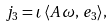Convert formula to latex. <formula><loc_0><loc_0><loc_500><loc_500>j _ { 3 } = \iota \, \langle A \, \omega , \, e _ { 3 } \rangle ,</formula> 